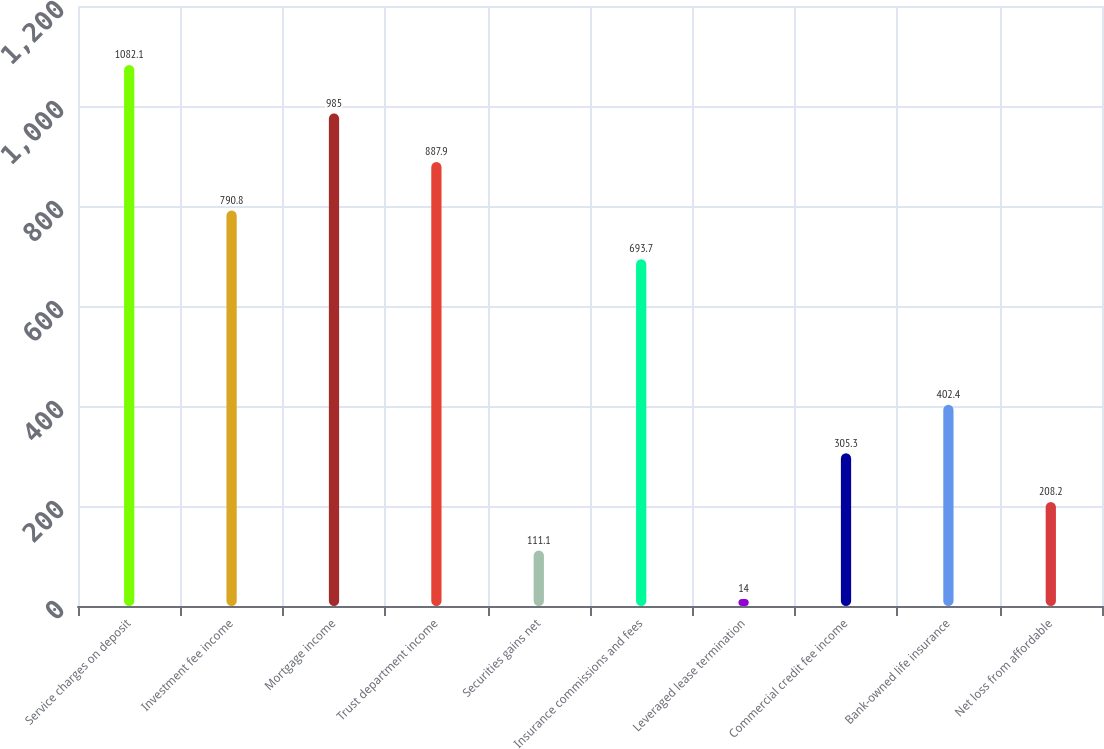Convert chart to OTSL. <chart><loc_0><loc_0><loc_500><loc_500><bar_chart><fcel>Service charges on deposit<fcel>Investment fee income<fcel>Mortgage income<fcel>Trust department income<fcel>Securities gains net<fcel>Insurance commissions and fees<fcel>Leveraged lease termination<fcel>Commercial credit fee income<fcel>Bank-owned life insurance<fcel>Net loss from affordable<nl><fcel>1082.1<fcel>790.8<fcel>985<fcel>887.9<fcel>111.1<fcel>693.7<fcel>14<fcel>305.3<fcel>402.4<fcel>208.2<nl></chart> 